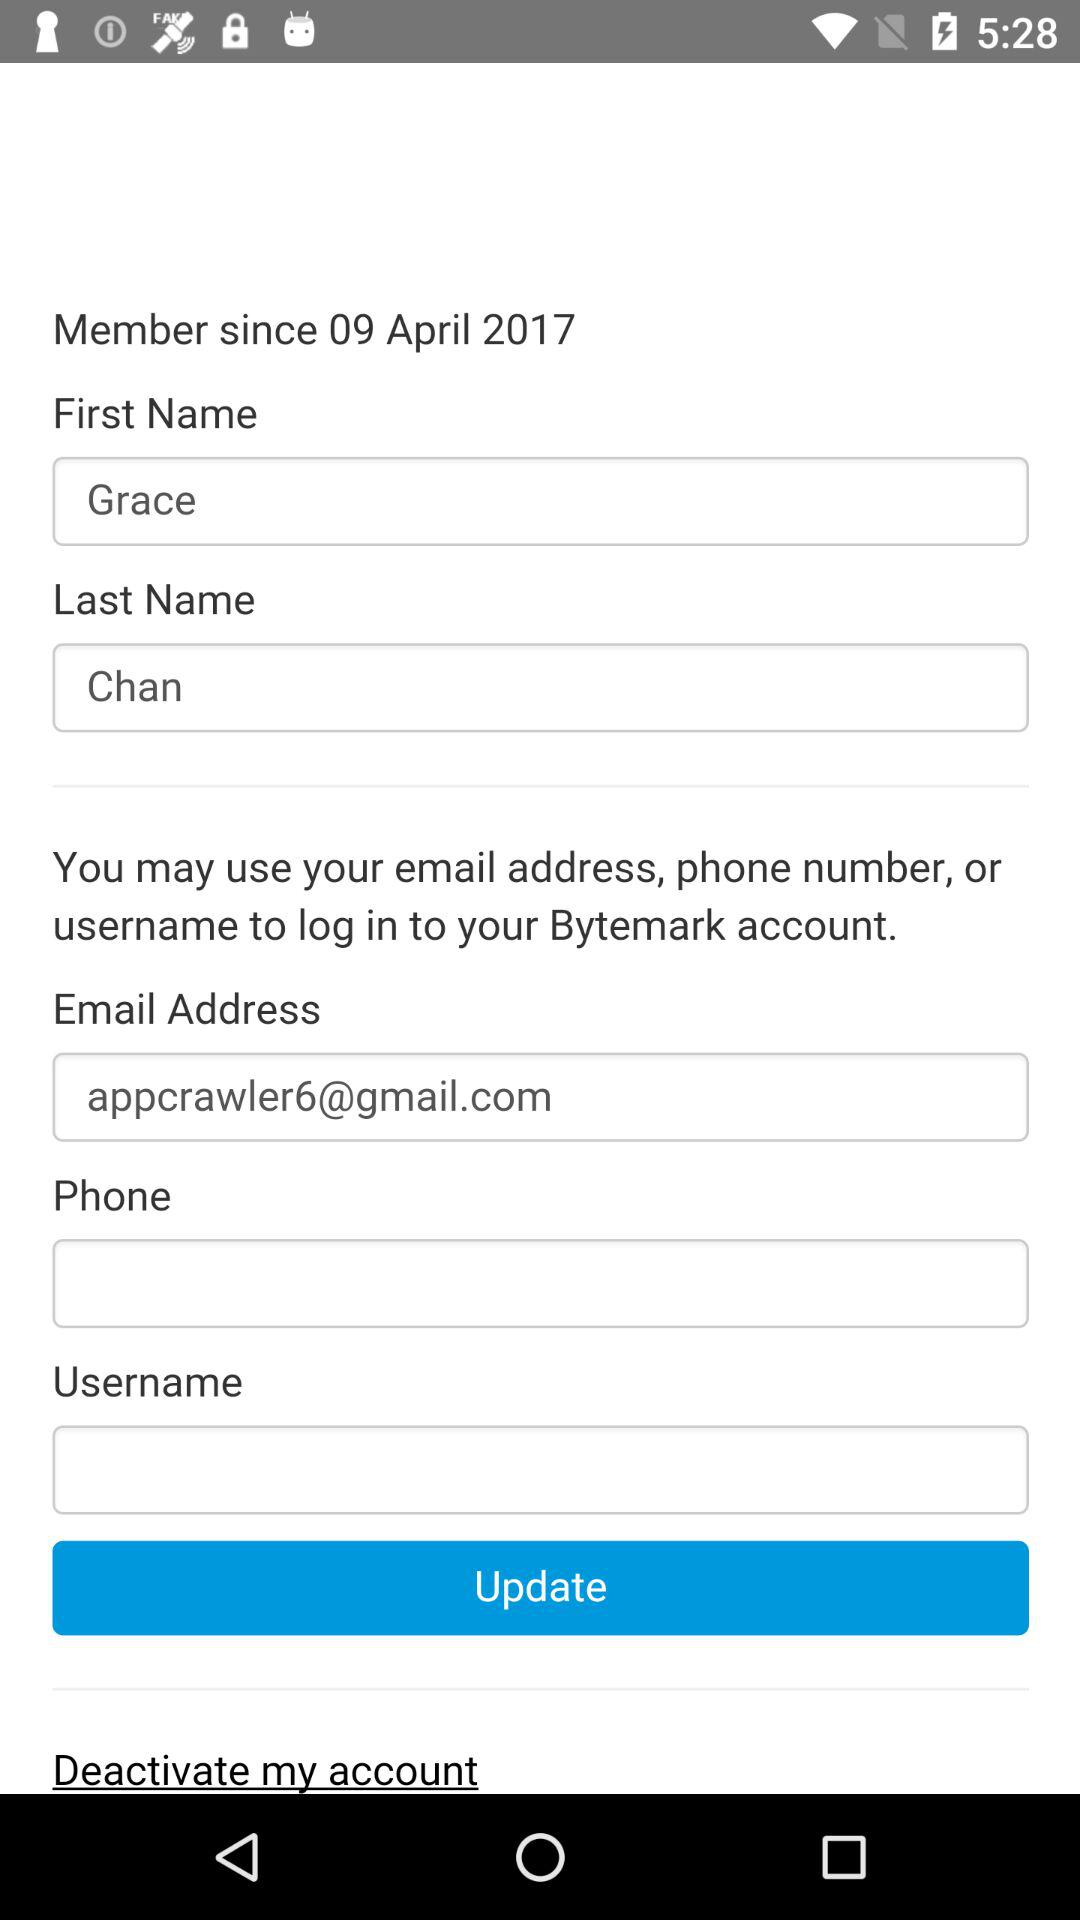What date is mentioned? The mentioned date is April 9, 2017. 